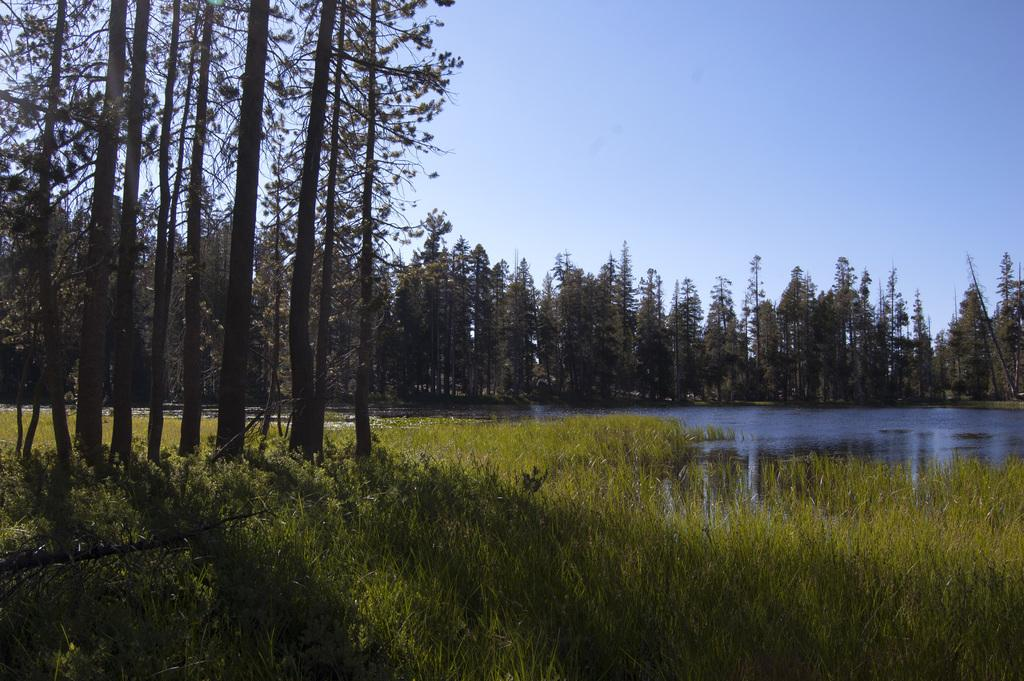What type of vegetation can be seen in the image? There is green-colored grass in the image. What other natural elements are present in the image? There are trees in the image. What can be seen besides the grass and trees? There is water visible in the image. What is the color of the sky in the image? The sky is blue and white in color. Where is the grandfather sitting with his cup of tea in the image? There is no grandfather or cup of tea present in the image. 